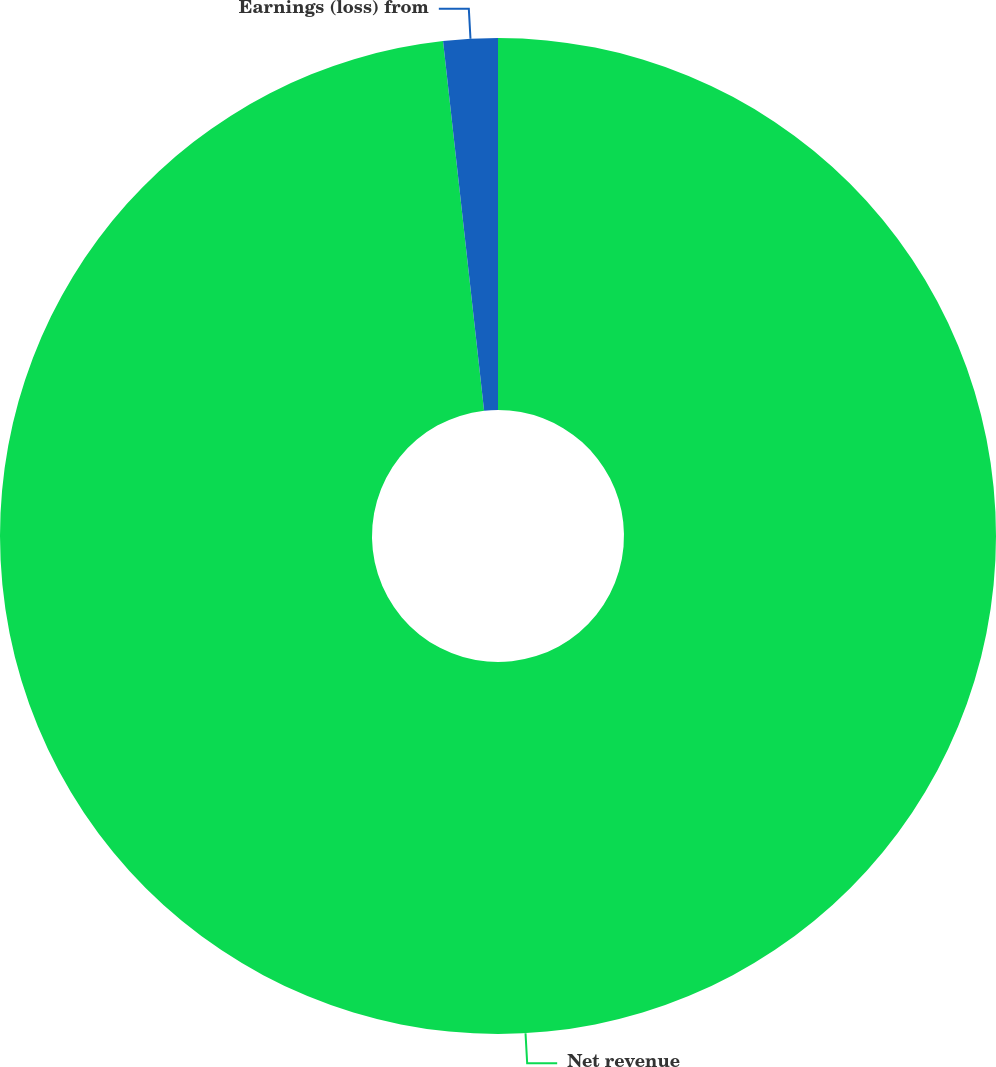<chart> <loc_0><loc_0><loc_500><loc_500><pie_chart><fcel>Net revenue<fcel>Earnings (loss) from<nl><fcel>98.24%<fcel>1.76%<nl></chart> 